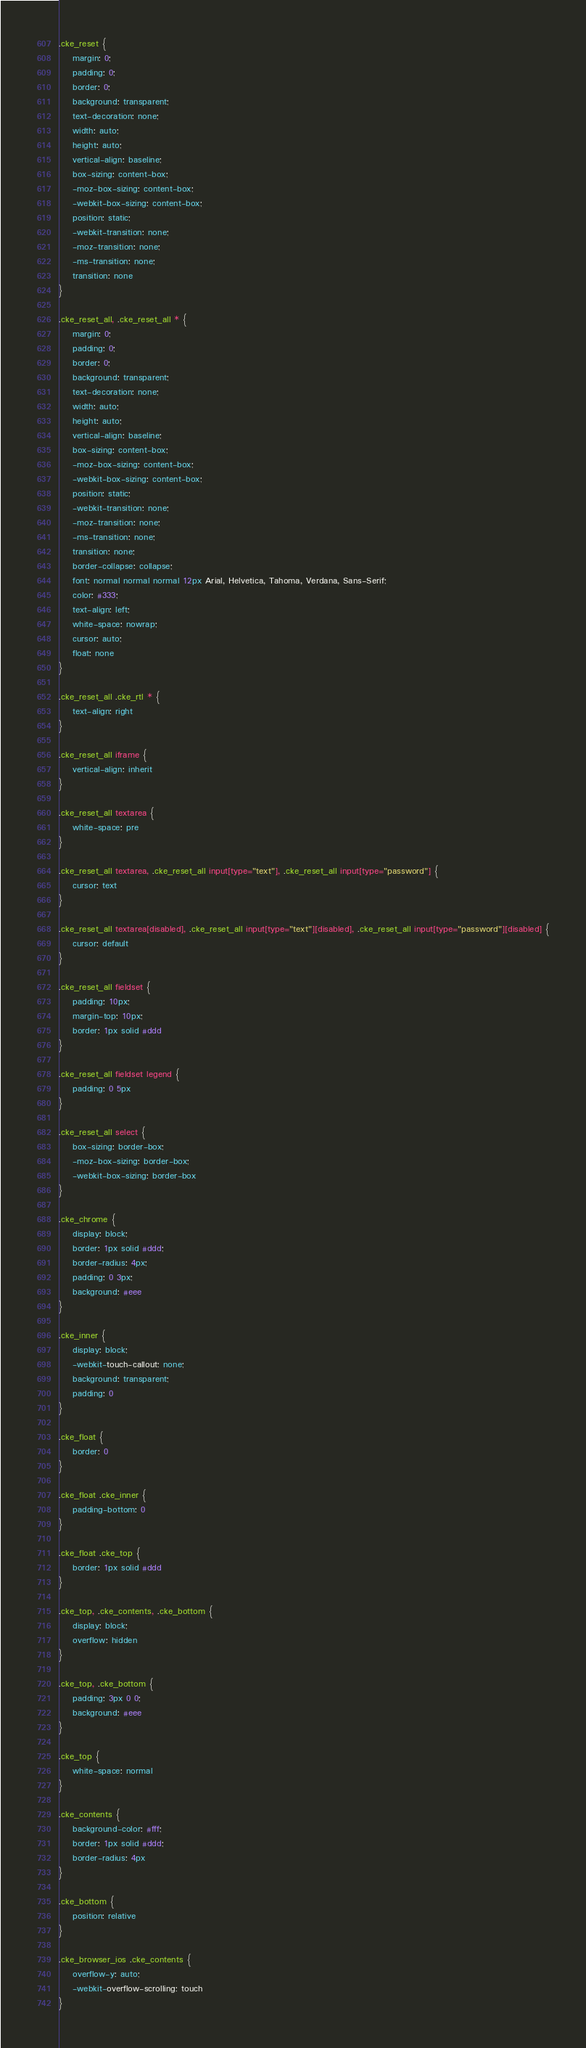Convert code to text. <code><loc_0><loc_0><loc_500><loc_500><_CSS_>.cke_reset {
    margin: 0;
    padding: 0;
    border: 0;
    background: transparent;
    text-decoration: none;
    width: auto;
    height: auto;
    vertical-align: baseline;
    box-sizing: content-box;
    -moz-box-sizing: content-box;
    -webkit-box-sizing: content-box;
    position: static;
    -webkit-transition: none;
    -moz-transition: none;
    -ms-transition: none;
    transition: none
}

.cke_reset_all, .cke_reset_all * {
    margin: 0;
    padding: 0;
    border: 0;
    background: transparent;
    text-decoration: none;
    width: auto;
    height: auto;
    vertical-align: baseline;
    box-sizing: content-box;
    -moz-box-sizing: content-box;
    -webkit-box-sizing: content-box;
    position: static;
    -webkit-transition: none;
    -moz-transition: none;
    -ms-transition: none;
    transition: none;
    border-collapse: collapse;
    font: normal normal normal 12px Arial, Helvetica, Tahoma, Verdana, Sans-Serif;
    color: #333;
    text-align: left;
    white-space: nowrap;
    cursor: auto;
    float: none
}

.cke_reset_all .cke_rtl * {
    text-align: right
}

.cke_reset_all iframe {
    vertical-align: inherit
}

.cke_reset_all textarea {
    white-space: pre
}

.cke_reset_all textarea, .cke_reset_all input[type="text"], .cke_reset_all input[type="password"] {
    cursor: text
}

.cke_reset_all textarea[disabled], .cke_reset_all input[type="text"][disabled], .cke_reset_all input[type="password"][disabled] {
    cursor: default
}

.cke_reset_all fieldset {
    padding: 10px;
    margin-top: 10px;
    border: 1px solid #ddd
}

.cke_reset_all fieldset legend {
    padding: 0 5px
}

.cke_reset_all select {
    box-sizing: border-box;
    -moz-box-sizing: border-box;
    -webkit-box-sizing: border-box
}

.cke_chrome {
    display: block;
    border: 1px solid #ddd;
    border-radius: 4px;
    padding: 0 3px;
    background: #eee
}

.cke_inner {
    display: block;
    -webkit-touch-callout: none;
    background: transparent;
    padding: 0
}

.cke_float {
    border: 0
}

.cke_float .cke_inner {
    padding-bottom: 0
}

.cke_float .cke_top {
    border: 1px solid #ddd
}

.cke_top, .cke_contents, .cke_bottom {
    display: block;
    overflow: hidden
}

.cke_top, .cke_bottom {
    padding: 3px 0 0;
    background: #eee
}

.cke_top {
    white-space: normal
}

.cke_contents {
    background-color: #fff;
    border: 1px solid #ddd;
    border-radius: 4px
}

.cke_bottom {
    position: relative
}

.cke_browser_ios .cke_contents {
    overflow-y: auto;
    -webkit-overflow-scrolling: touch
}
</code> 